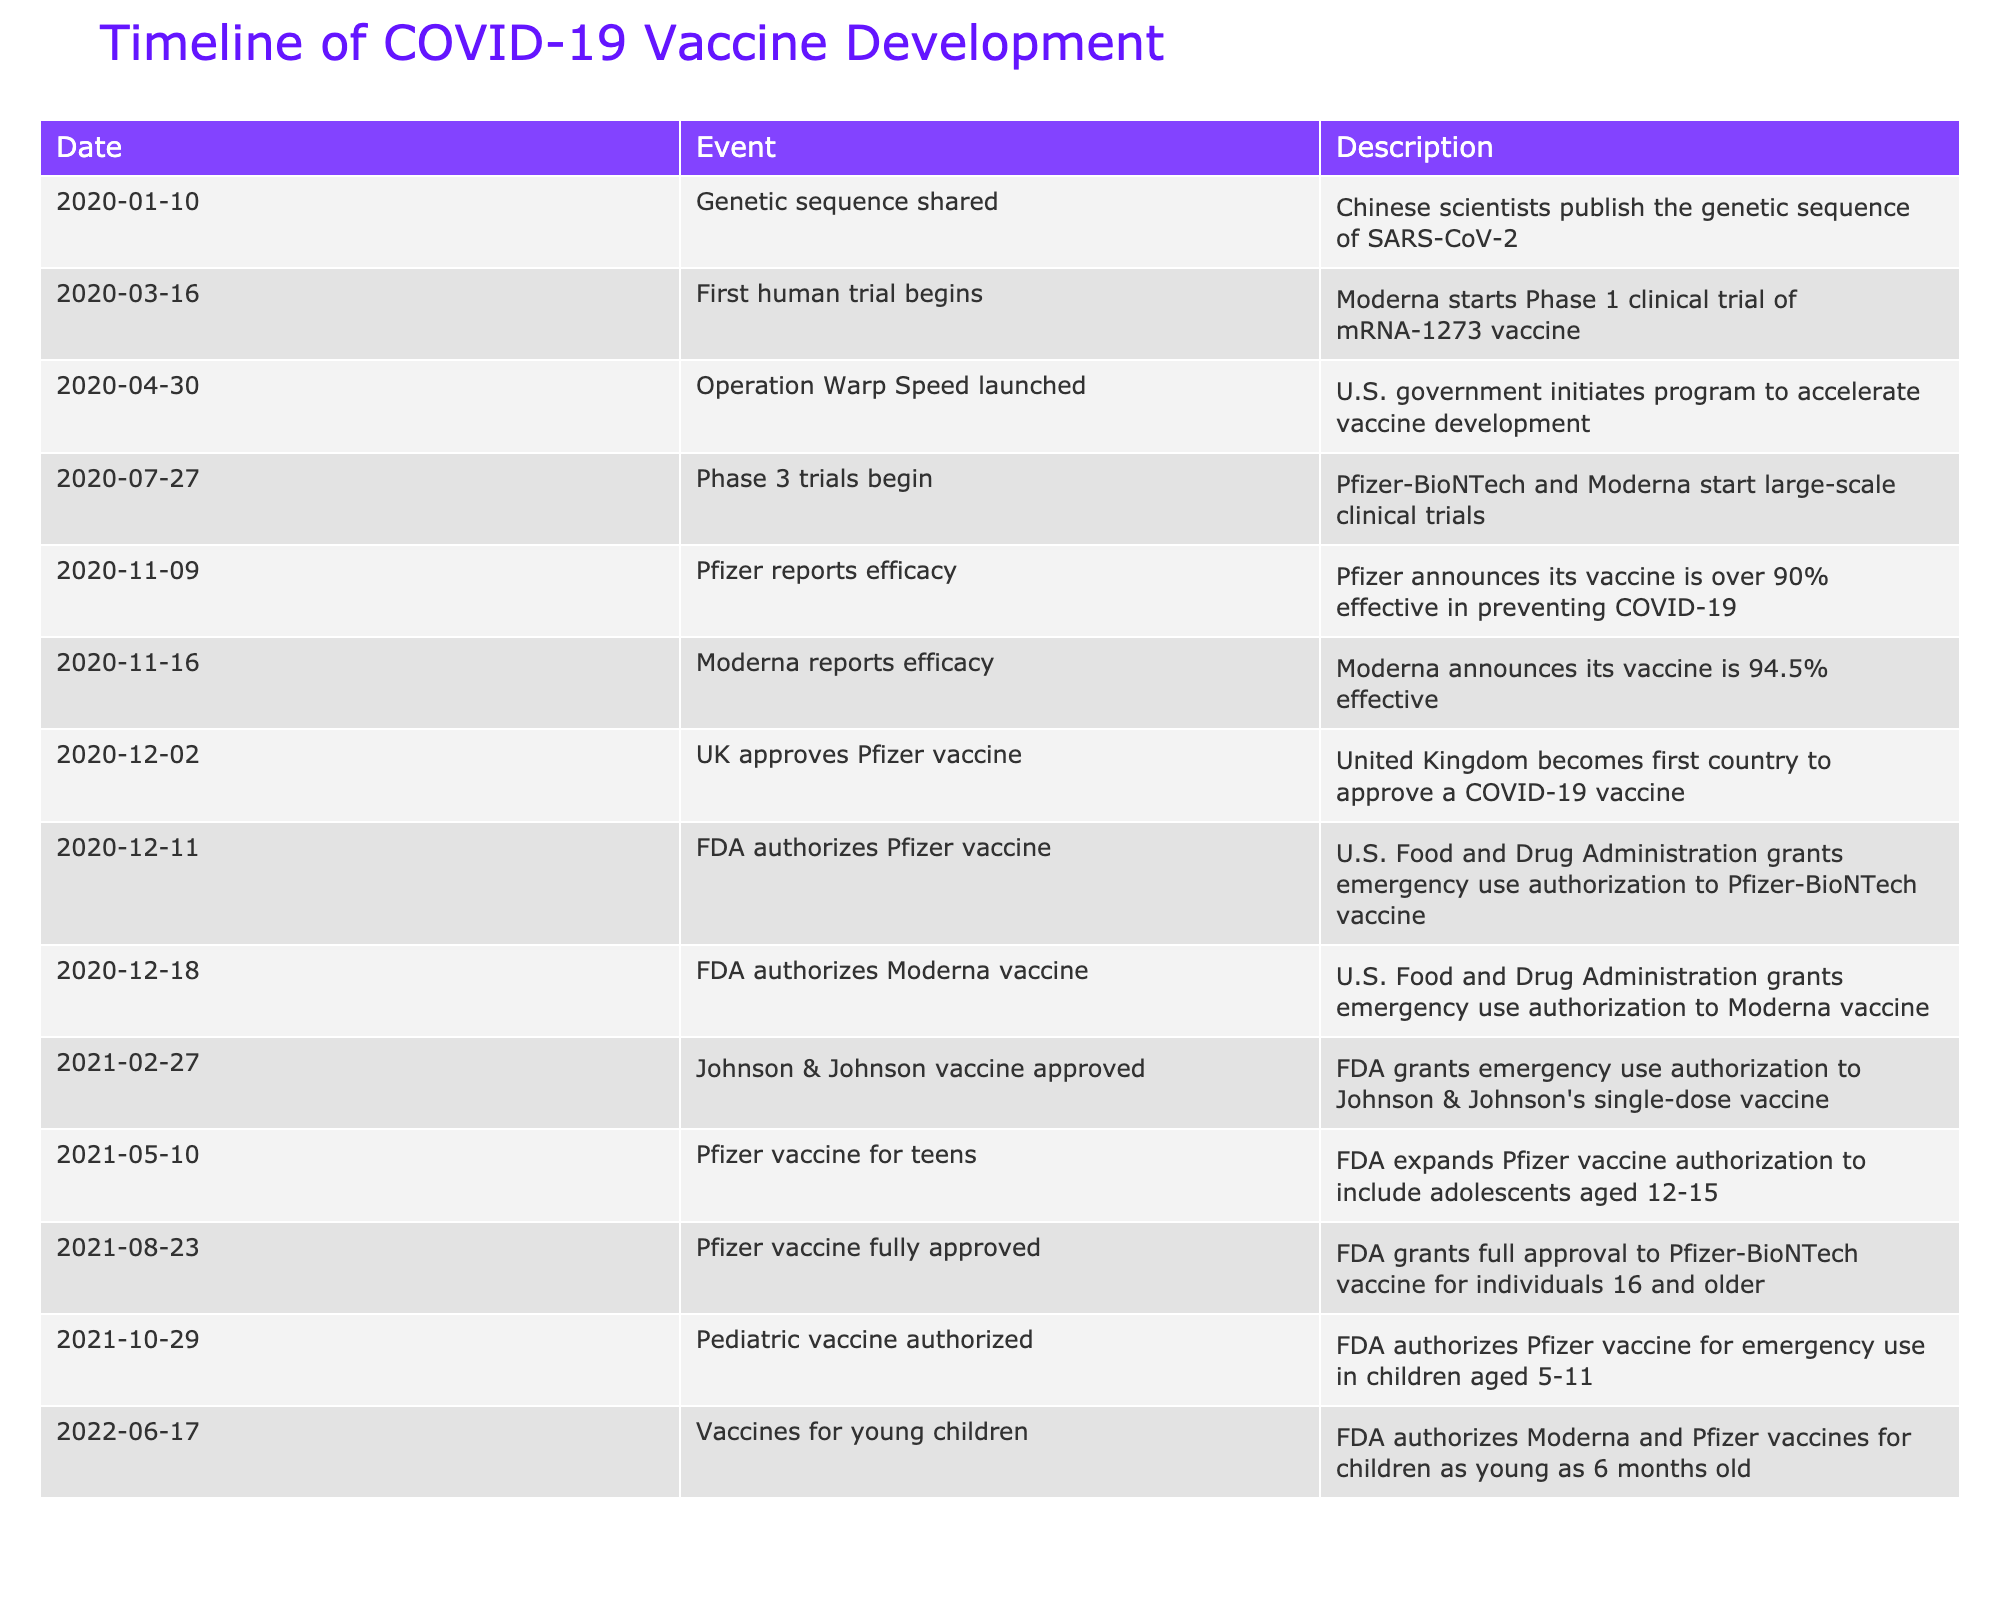What date did the UK approve the Pfizer vaccine? According to the table, the UK approved the Pfizer vaccine on December 2, 2020. This can be directly retrieved from the "Date" column corresponding to the event labeled as "UK approves Pfizer vaccine."
Answer: December 2, 2020 Which vaccine was reported to be 94.5% effective, and when was this announced? The Moderna vaccine was reported to be 94.5% effective on November 16, 2020. This information is found in the "Description" of the entry for that date.
Answer: Moderna vaccine, November 16, 2020 How many vaccines received emergency use authorization from the FDA in December 2020? The table shows two vaccines that received FDA emergency use authorization in December 2020: the Pfizer vaccine on December 11 and the Moderna vaccine on December 18. Thus, the total is two.
Answer: 2 Was the Johnson & Johnson vaccine approved before the FDA fully approved the Pfizer vaccine? Yes, the Johnson & Johnson vaccine was approved on February 27, 2021, while the Pfizer vaccine received full approval on August 23, 2021. This can be verified in the table where the dates indicate the sequence of approvals.
Answer: Yes What is the difference in days between the announcement of Pfizer's and Moderna's vaccine efficacy? Pfizer's vaccine efficacy was reported on November 9, 2020, and Moderna's efficacy was reported on November 16, 2020. The difference in days is 7 days (November 16 minus November 9). The calculation involves counting the days between the two dates.
Answer: 7 days What was the first event in the timeline, and what was its significance? The first event in the timeline is the sharing of the genetic sequence on January 10, 2020. This was significant because it allowed scientists globally to begin studying the virus, leading to the rapid development of vaccines.
Answer: Genetic sequence shared, significance: initiated global research How many total vaccine approvals by the FDA are listed in the table? The table indicates that there are four vaccine approvals granted by the FDA: Pfizer on December 11, 2020; Moderna on December 18, 2020; Johnson & Johnson on February 27, 2021; and full approval for Pfizer on August 23, 2021. The total of these approvals is four.
Answer: 4 What percentage efficacy was reported for the Pfizer vaccine? The Pfizer vaccine was announced to be over 90% effective on November 9, 2020, as specified in the table. This figure is directly stated in the "Description" column associated with that date.
Answer: Over 90% How many months passed from the start of the Phase 1 clinical trial to the first emergency use authorization in the U.S.? The Phase 1 clinical trial for Moderna started on March 16, 2020, and the first emergency use authorization in the U.S. was for the Pfizer vaccine on December 11, 2020. The period between these dates is approximately 8 months (accounting for March to December). Counting the number of months between these two dates gives us the solution.
Answer: 8 months 